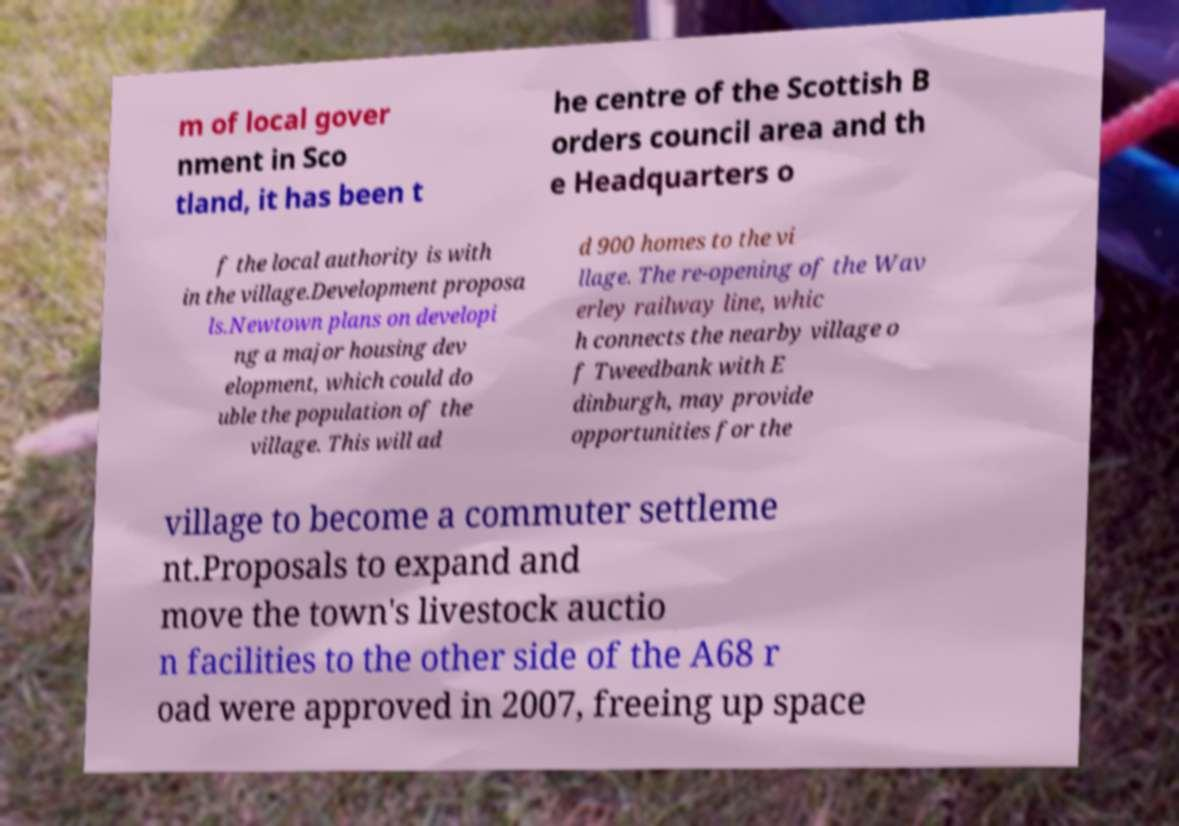Could you assist in decoding the text presented in this image and type it out clearly? m of local gover nment in Sco tland, it has been t he centre of the Scottish B orders council area and th e Headquarters o f the local authority is with in the village.Development proposa ls.Newtown plans on developi ng a major housing dev elopment, which could do uble the population of the village. This will ad d 900 homes to the vi llage. The re-opening of the Wav erley railway line, whic h connects the nearby village o f Tweedbank with E dinburgh, may provide opportunities for the village to become a commuter settleme nt.Proposals to expand and move the town's livestock auctio n facilities to the other side of the A68 r oad were approved in 2007, freeing up space 